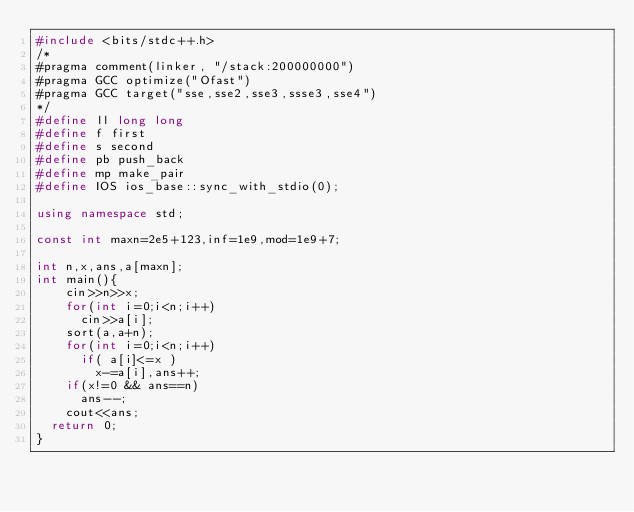Convert code to text. <code><loc_0><loc_0><loc_500><loc_500><_C++_>#include <bits/stdc++.h>
/*
#pragma comment(linker, "/stack:200000000")
#pragma GCC optimize("Ofast")
#pragma GCC target("sse,sse2,sse3,ssse3,sse4")
*/
#define ll long long                   
#define f first 
#define s second 
#define pb push_back               
#define mp make_pair 
#define IOS ios_base::sync_with_stdio(0);

using namespace std;                    

const int maxn=2e5+123,inf=1e9,mod=1e9+7;

int n,x,ans,a[maxn];
int main(){
    cin>>n>>x;
    for(int i=0;i<n;i++)
    	cin>>a[i];
    sort(a,a+n);
    for(int i=0;i<n;i++)
    	if( a[i]<=x )
    		x-=a[i],ans++;
    if(x!=0 && ans==n)
    	ans--;
    cout<<ans;
	return 0;
}
</code> 